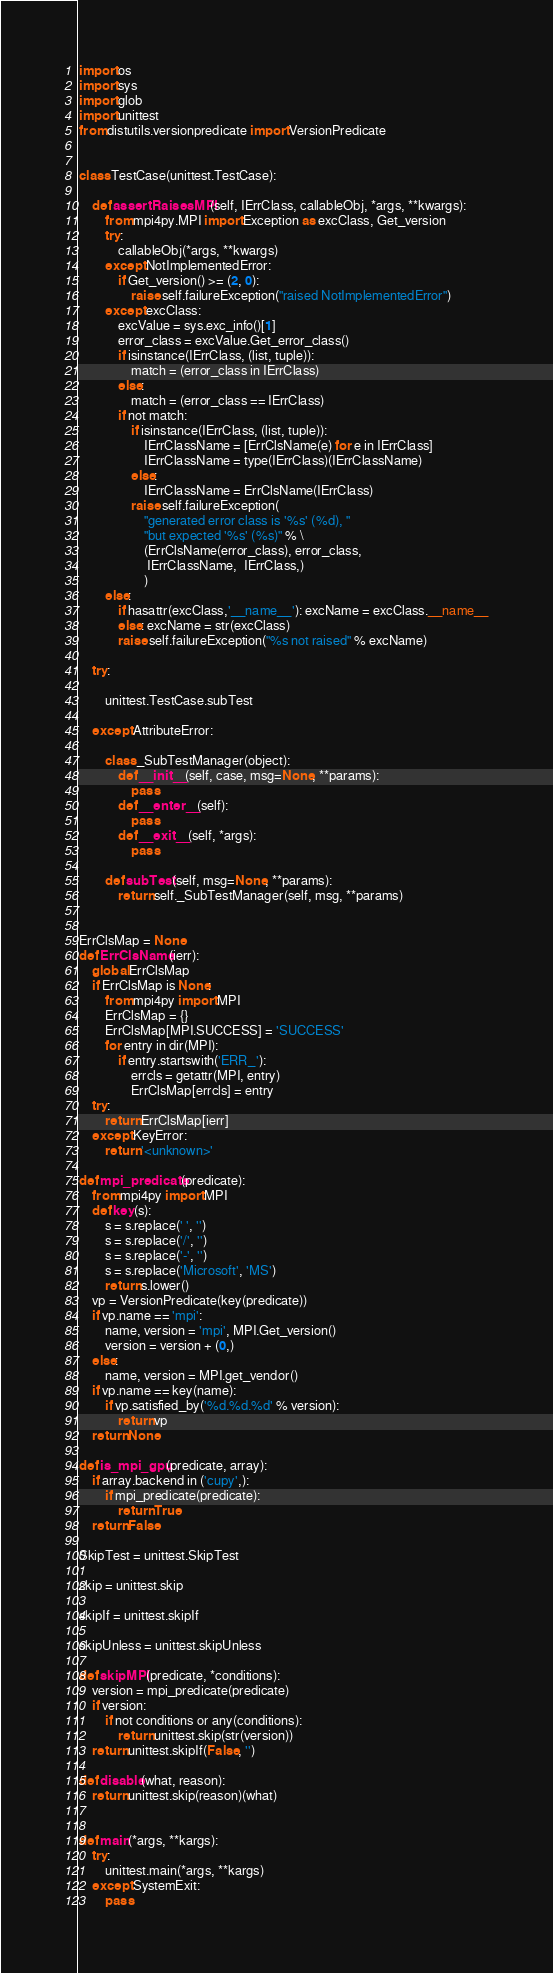Convert code to text. <code><loc_0><loc_0><loc_500><loc_500><_Python_>import os
import sys
import glob
import unittest
from distutils.versionpredicate import VersionPredicate


class TestCase(unittest.TestCase):

    def assertRaisesMPI(self, IErrClass, callableObj, *args, **kwargs):
        from mpi4py.MPI import Exception as excClass, Get_version
        try:
            callableObj(*args, **kwargs)
        except NotImplementedError:
            if Get_version() >= (2, 0):
                raise self.failureException("raised NotImplementedError")
        except excClass:
            excValue = sys.exc_info()[1]
            error_class = excValue.Get_error_class()
            if isinstance(IErrClass, (list, tuple)):
                match = (error_class in IErrClass)
            else:
                match = (error_class == IErrClass)
            if not match:
                if isinstance(IErrClass, (list, tuple)):
                    IErrClassName = [ErrClsName(e) for e in IErrClass]
                    IErrClassName = type(IErrClass)(IErrClassName)
                else:
                    IErrClassName = ErrClsName(IErrClass)
                raise self.failureException(
                    "generated error class is '%s' (%d), "
                    "but expected '%s' (%s)" % \
                    (ErrClsName(error_class), error_class,
                     IErrClassName,  IErrClass,)
                    )
        else:
            if hasattr(excClass,'__name__'): excName = excClass.__name__
            else: excName = str(excClass)
            raise self.failureException("%s not raised" % excName)

    try:

        unittest.TestCase.subTest

    except AttributeError:

        class _SubTestManager(object):
            def __init__(self, case, msg=None, **params):
                pass
            def __enter__(self):
                pass
            def __exit__(self, *args):
                pass

        def subTest(self, msg=None, **params):
            return self._SubTestManager(self, msg, **params)


ErrClsMap = None
def ErrClsName(ierr):
    global ErrClsMap
    if ErrClsMap is None:
        from mpi4py import MPI
        ErrClsMap = {}
        ErrClsMap[MPI.SUCCESS] = 'SUCCESS'
        for entry in dir(MPI):
            if entry.startswith('ERR_'):
                errcls = getattr(MPI, entry)
                ErrClsMap[errcls] = entry
    try:
        return ErrClsMap[ierr]
    except KeyError:
        return '<unknown>'

def mpi_predicate(predicate):
    from mpi4py import MPI
    def key(s):
        s = s.replace(' ', '')
        s = s.replace('/', '')
        s = s.replace('-', '')
        s = s.replace('Microsoft', 'MS')
        return s.lower()
    vp = VersionPredicate(key(predicate))
    if vp.name == 'mpi':
        name, version = 'mpi', MPI.Get_version()
        version = version + (0,)
    else:
        name, version = MPI.get_vendor()
    if vp.name == key(name):
        if vp.satisfied_by('%d.%d.%d' % version):
            return vp
    return None

def is_mpi_gpu(predicate, array):
    if array.backend in ('cupy',):
        if mpi_predicate(predicate):
            return True
    return False

SkipTest = unittest.SkipTest

skip = unittest.skip

skipIf = unittest.skipIf

skipUnless = unittest.skipUnless

def skipMPI(predicate, *conditions):
    version = mpi_predicate(predicate)
    if version:
        if not conditions or any(conditions):
            return unittest.skip(str(version))
    return unittest.skipIf(False, '')

def disable(what, reason):
    return unittest.skip(reason)(what)


def main(*args, **kargs):
    try:
        unittest.main(*args, **kargs)
    except SystemExit:
        pass
</code> 